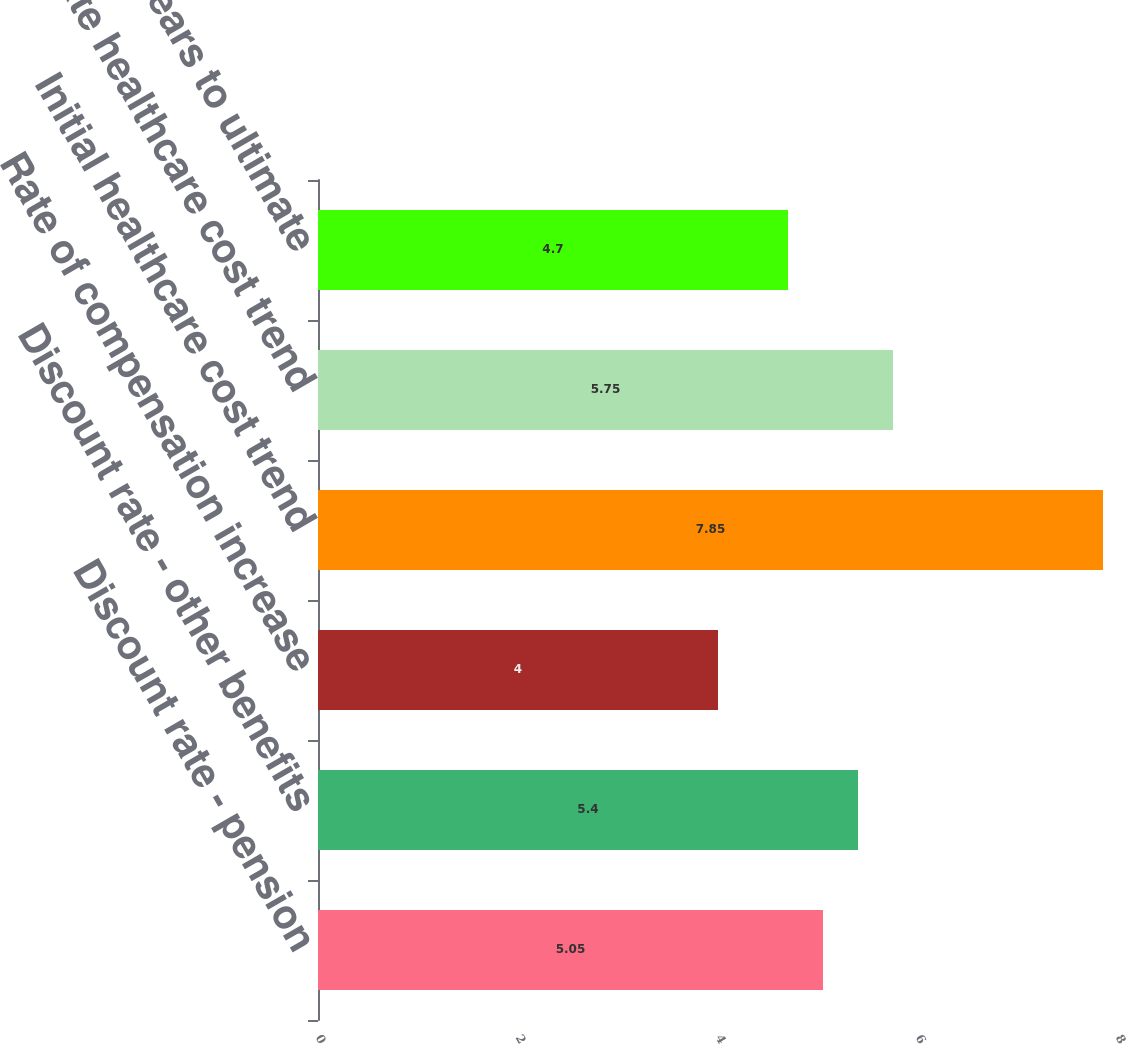Convert chart to OTSL. <chart><loc_0><loc_0><loc_500><loc_500><bar_chart><fcel>Discount rate - pension<fcel>Discount rate - other benefits<fcel>Rate of compensation increase<fcel>Initial healthcare cost trend<fcel>Ultimate healthcare cost trend<fcel>Number of years to ultimate<nl><fcel>5.05<fcel>5.4<fcel>4<fcel>7.85<fcel>5.75<fcel>4.7<nl></chart> 